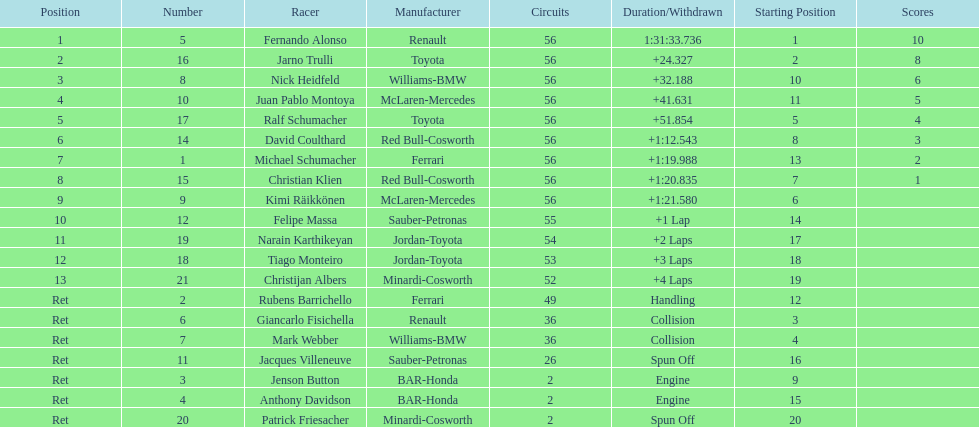How many bmws finished before webber? 1. 